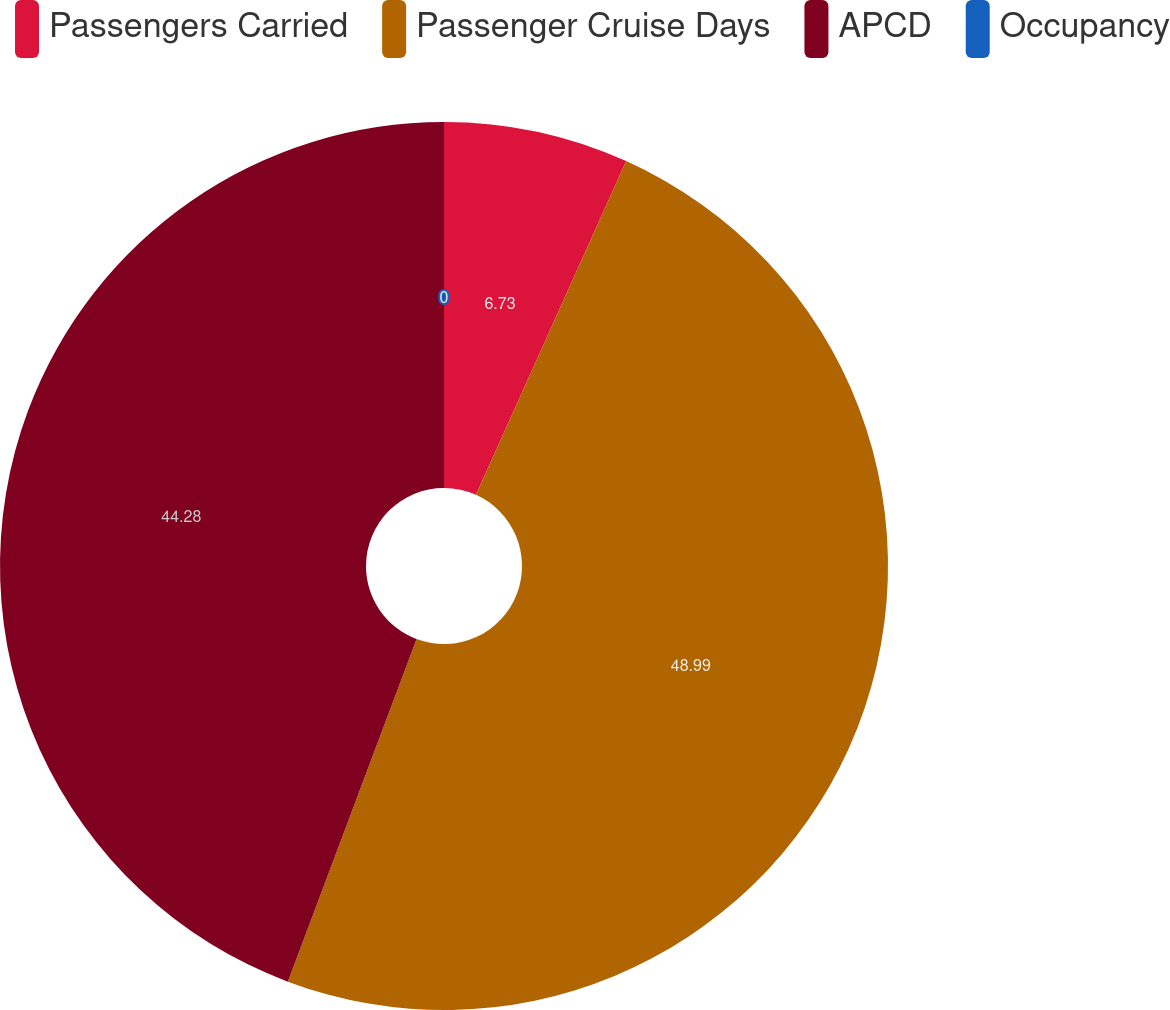Convert chart. <chart><loc_0><loc_0><loc_500><loc_500><pie_chart><fcel>Passengers Carried<fcel>Passenger Cruise Days<fcel>APCD<fcel>Occupancy<nl><fcel>6.73%<fcel>48.99%<fcel>44.28%<fcel>0.0%<nl></chart> 